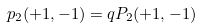<formula> <loc_0><loc_0><loc_500><loc_500>p _ { 2 } ( + 1 , - 1 ) = q P _ { 2 } ( + 1 , - 1 )</formula> 